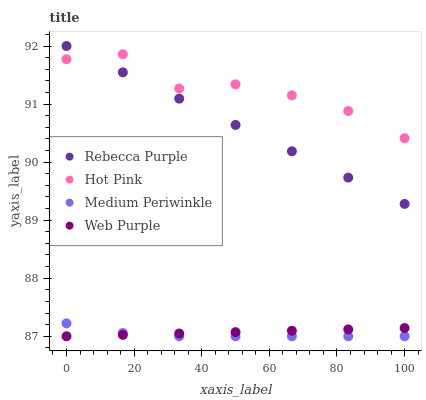Does Medium Periwinkle have the minimum area under the curve?
Answer yes or no. Yes. Does Hot Pink have the maximum area under the curve?
Answer yes or no. Yes. Does Hot Pink have the minimum area under the curve?
Answer yes or no. No. Does Medium Periwinkle have the maximum area under the curve?
Answer yes or no. No. Is Rebecca Purple the smoothest?
Answer yes or no. Yes. Is Hot Pink the roughest?
Answer yes or no. Yes. Is Medium Periwinkle the smoothest?
Answer yes or no. No. Is Medium Periwinkle the roughest?
Answer yes or no. No. Does Web Purple have the lowest value?
Answer yes or no. Yes. Does Hot Pink have the lowest value?
Answer yes or no. No. Does Rebecca Purple have the highest value?
Answer yes or no. Yes. Does Hot Pink have the highest value?
Answer yes or no. No. Is Web Purple less than Hot Pink?
Answer yes or no. Yes. Is Rebecca Purple greater than Web Purple?
Answer yes or no. Yes. Does Hot Pink intersect Rebecca Purple?
Answer yes or no. Yes. Is Hot Pink less than Rebecca Purple?
Answer yes or no. No. Is Hot Pink greater than Rebecca Purple?
Answer yes or no. No. Does Web Purple intersect Hot Pink?
Answer yes or no. No. 